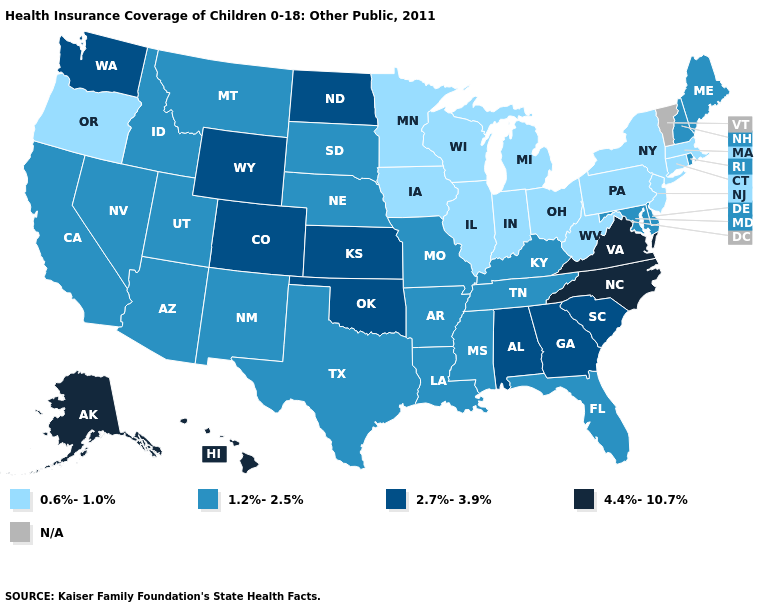Does Virginia have the highest value in the USA?
Be succinct. Yes. What is the highest value in the South ?
Keep it brief. 4.4%-10.7%. Does Oklahoma have the highest value in the USA?
Give a very brief answer. No. What is the value of Illinois?
Write a very short answer. 0.6%-1.0%. Name the states that have a value in the range N/A?
Concise answer only. Vermont. Name the states that have a value in the range 1.2%-2.5%?
Concise answer only. Arizona, Arkansas, California, Delaware, Florida, Idaho, Kentucky, Louisiana, Maine, Maryland, Mississippi, Missouri, Montana, Nebraska, Nevada, New Hampshire, New Mexico, Rhode Island, South Dakota, Tennessee, Texas, Utah. What is the value of Kansas?
Be succinct. 2.7%-3.9%. What is the highest value in the Northeast ?
Write a very short answer. 1.2%-2.5%. Among the states that border Pennsylvania , does Delaware have the lowest value?
Write a very short answer. No. What is the highest value in states that border Indiana?
Keep it brief. 1.2%-2.5%. What is the value of Arizona?
Write a very short answer. 1.2%-2.5%. Does the first symbol in the legend represent the smallest category?
Answer briefly. Yes. Among the states that border Missouri , does Kansas have the highest value?
Write a very short answer. Yes. What is the value of Ohio?
Keep it brief. 0.6%-1.0%. Does Utah have the lowest value in the USA?
Write a very short answer. No. 